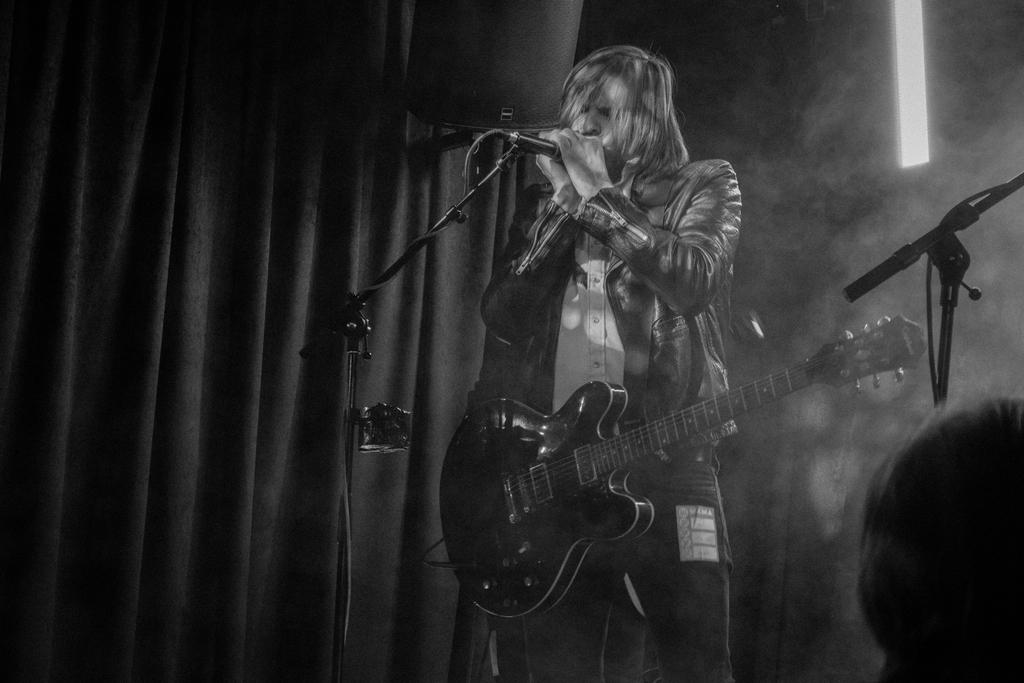What is the person in the image doing? The person is standing and singing in the image. What is the person holding in front of them? There is a microphone in front of the person. What type of clothing is the person wearing? The person is wearing a guitar. What can be seen in the background of the image? There is sunlight, curtains, and a wall in the background. What type of scarf is the person wearing in the image? There is no scarf visible in the image; the person is wearing a guitar. Can you see a lake in the background of the image? No, there is no lake present in the image; the background features sunlight, curtains, and a wall. 